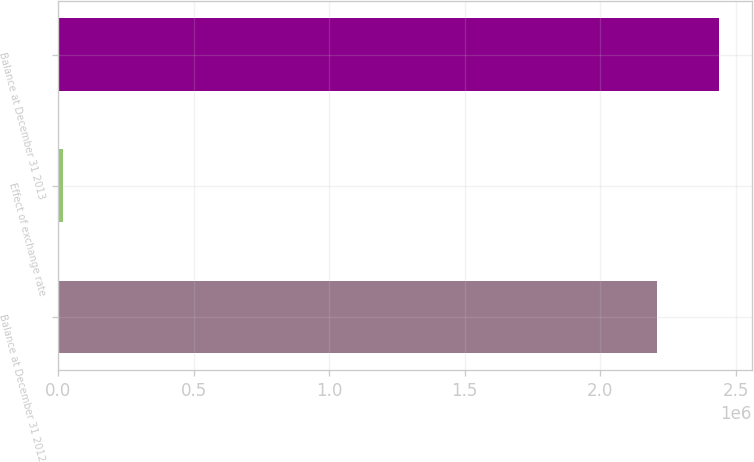Convert chart to OTSL. <chart><loc_0><loc_0><loc_500><loc_500><bar_chart><fcel>Balance at December 31 2012<fcel>Effect of exchange rate<fcel>Balance at December 31 2013<nl><fcel>2.21095e+06<fcel>17134<fcel>2.4374e+06<nl></chart> 